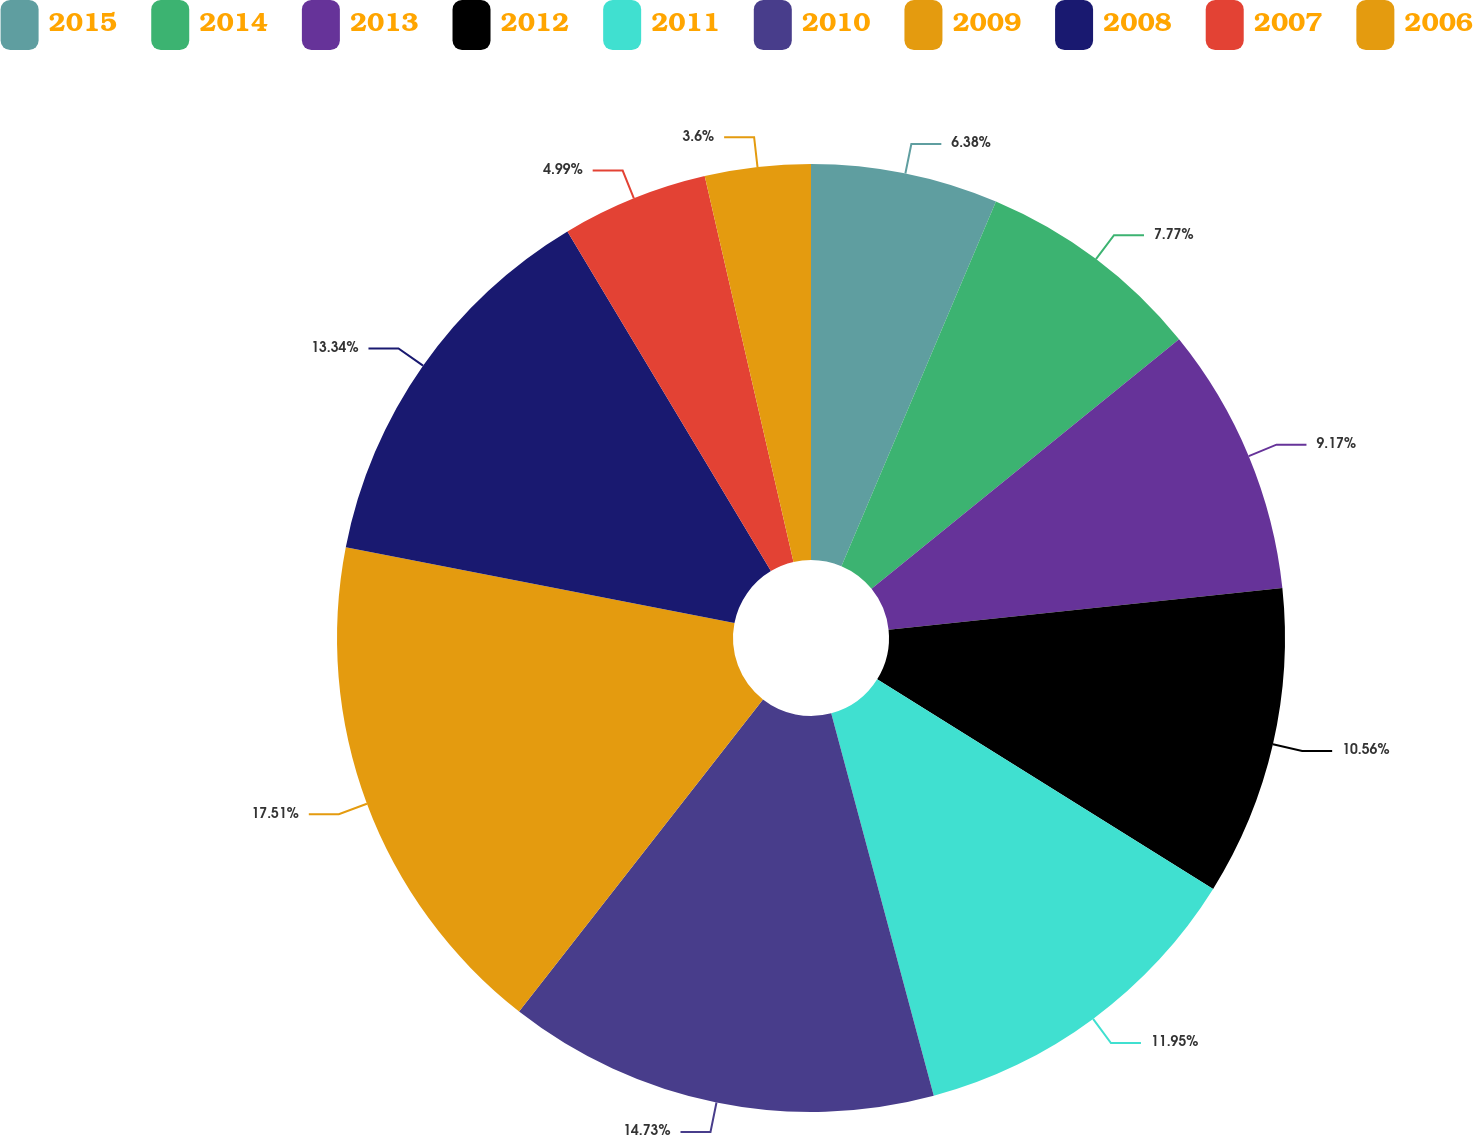<chart> <loc_0><loc_0><loc_500><loc_500><pie_chart><fcel>2015<fcel>2014<fcel>2013<fcel>2012<fcel>2011<fcel>2010<fcel>2009<fcel>2008<fcel>2007<fcel>2006<nl><fcel>6.38%<fcel>7.77%<fcel>9.17%<fcel>10.56%<fcel>11.95%<fcel>14.73%<fcel>17.51%<fcel>13.34%<fcel>4.99%<fcel>3.6%<nl></chart> 